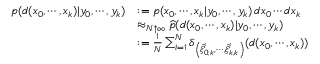Convert formula to latex. <formula><loc_0><loc_0><loc_500><loc_500>{ \begin{array} { r l } { p ( d ( x _ { 0 } , \cdots , x _ { k } ) | y _ { 0 } , \cdots , y _ { k } ) } & { \colon = p ( x _ { 0 } , \cdots , x _ { k } | y _ { 0 } , \cdots , y _ { k } ) \, d x _ { 0 } \cdots d x _ { k } } \\ & { \approx _ { N \uparrow \infty } { \widehat { p } } ( d ( x _ { 0 } , \cdots , x _ { k } ) | y _ { 0 } , \cdots , y _ { k } ) } \\ & { \colon = { \frac { 1 } { N } } \sum _ { i = 1 } ^ { N } \delta _ { \left ( { \widehat { \xi } } _ { 0 , k } ^ { i } , \cdots , { \widehat { \xi } } _ { k , k } ^ { i } \right ) } ( d ( x _ { 0 } , \cdots , x _ { k } ) ) } \end{array} }</formula> 